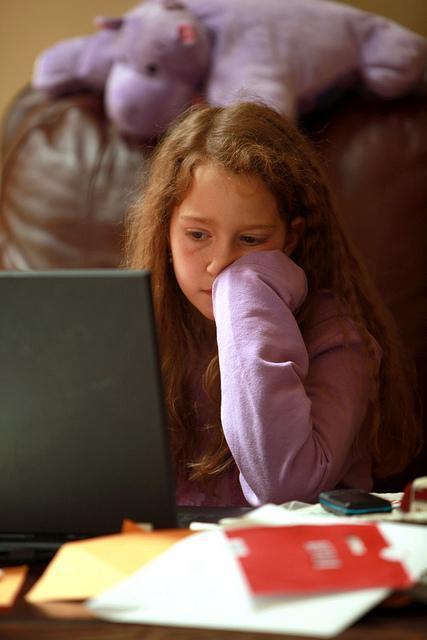How many buses are there?
Give a very brief answer. 0. 